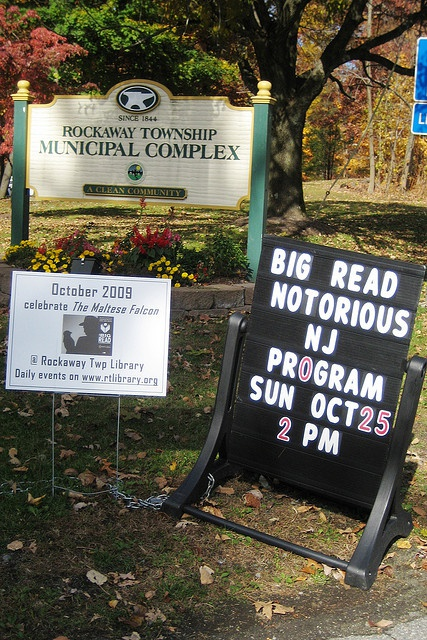Describe the objects in this image and their specific colors. I can see various objects in this image with different colors. 